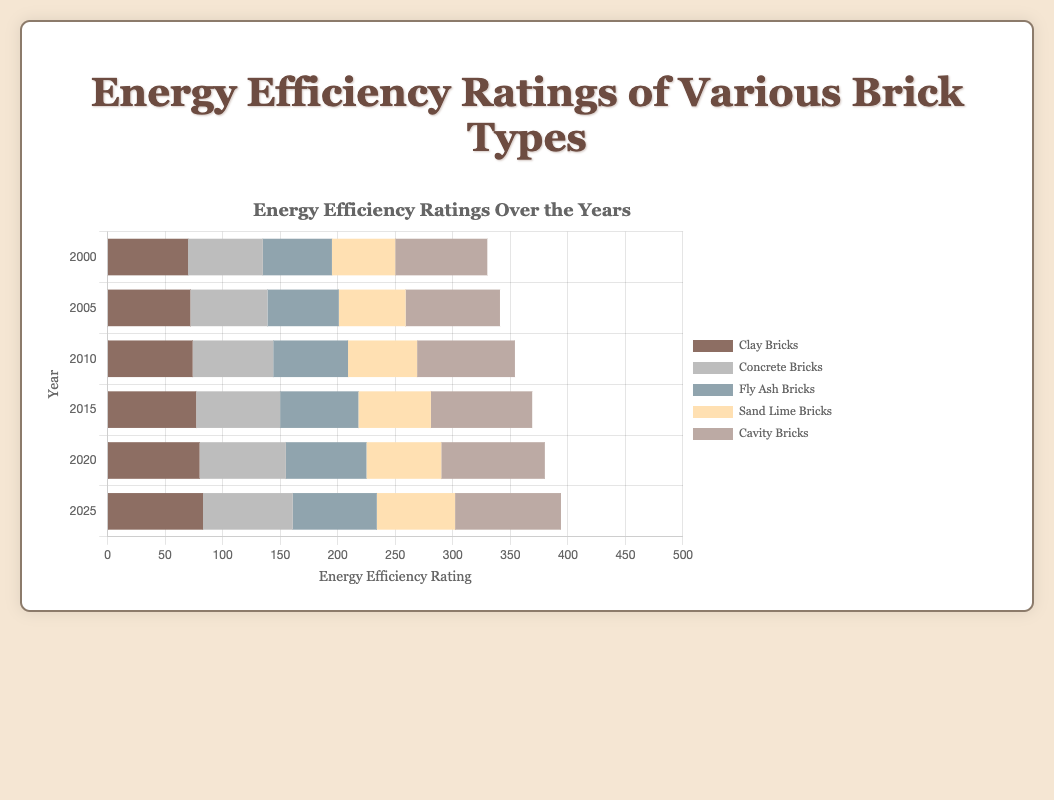Which brick type consistently shows the highest energy efficiency rating over the years? Looking at the graph, Cavity Bricks consistently have the highest energy efficiency rating in each displayed year.
Answer: Cavity Bricks How much did the energy efficiency rating of Clay Bricks improve from the year 2000 to 2025? The energy efficiency rating of Clay Bricks in 2000 was 70 and in 2025 it is 83. The improvement is 83 - 70 = 13.
Answer: 13 What is the average energy efficiency rating of Fly Ash Bricks across the years shown? Sum of Fly Ash Bricks ratings across the years: 60 + 62 + 65 + 68 + 70 + 73 = 398. The number of years is 6, so the average is 398 / 6 ≈ 66.33.
Answer: 66.33 Which brick type had a lower energy efficiency rating in 2020 compared to Concrete Bricks in 2015? In 2020, Fly Ash Bricks and Sand Lime Bricks had lower ratings compared to Concrete Bricks in 2015, which was 73. Fly Ash Bricks had 70 and Sand Lime Bricks had 65 in 2020.
Answer: Fly Ash Bricks and Sand Lime Bricks In the year 2025, which brick type has the smallest increase in energy efficiency rating compared to the year 2000? Calculating the increase for each type from 2000 to 2025:
Clay Bricks: 83 - 70 = 13
Concrete Bricks: 78 - 65 = 13
Fly Ash Bricks: 73 - 60 = 13
Sand Lime Bricks: 68 - 55 = 13
Cavity Bricks: 92 - 80 = 12
The smallest increase is observed in Cavity Bricks.
Answer: Cavity Bricks Which years showed an increasing trend for Concrete Bricks' energy efficiency rating? Concrete Bricks' ratings are: 2000: 65, 2005: 67, 2010: 70, 2015: 73, 2020: 75, 2025: 78. The rating increased every year.
Answer: Every year What's the sum of the energy efficiency ratings of Sand Lime Bricks from 2000 to 2025? Sum of Sand Lime Bricks ratings: 55 (2000) + 58 (2005) + 60 (2010) + 63 (2015) + 65 (2020) + 68 (2025) = 369.
Answer: 369 Between the years 2010 and 2020, which brick type saw the highest overall increase in its energy efficiency rating? Calculating the increase from 2010 to 2020:
Clay Bricks: 80 - 74 = 6
Concrete Bricks: 75 - 70 = 5
Fly Ash Bricks: 70 - 65 = 5
Sand Lime Bricks: 65 - 60 = 5
Cavity Bricks: 90 - 85 = 5
The highest increase is observed in Clay Bricks.
Answer: Clay Bricks 